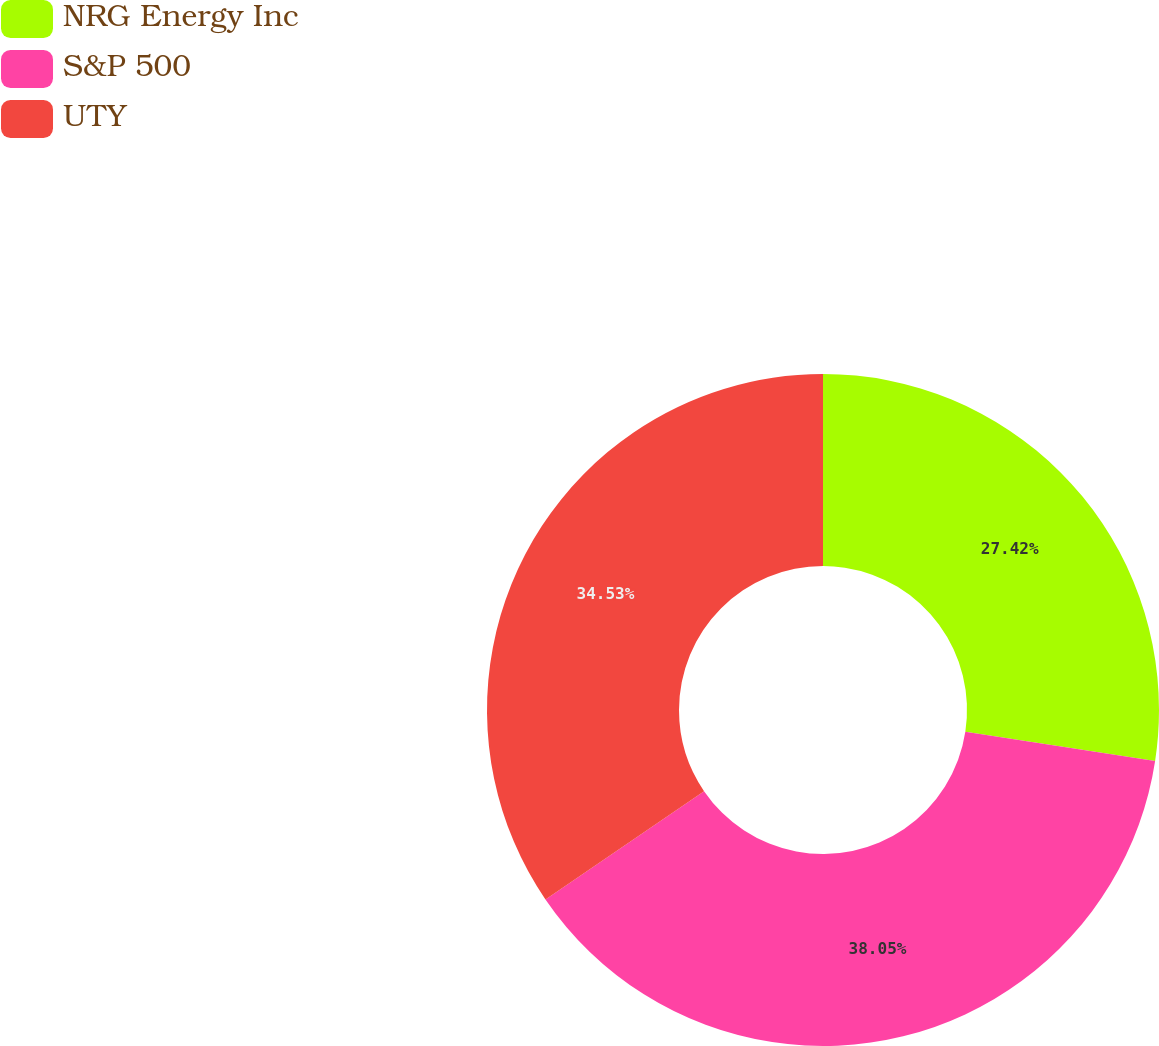Convert chart. <chart><loc_0><loc_0><loc_500><loc_500><pie_chart><fcel>NRG Energy Inc<fcel>S&P 500<fcel>UTY<nl><fcel>27.42%<fcel>38.05%<fcel>34.53%<nl></chart> 